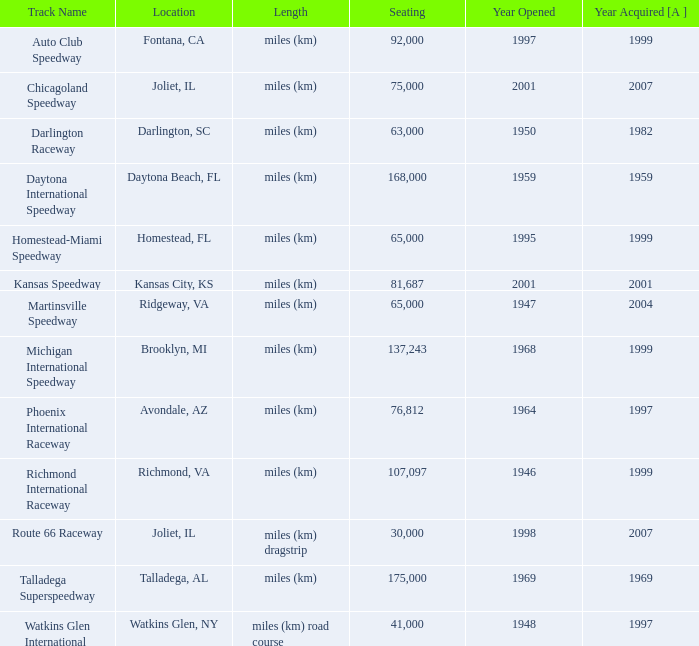In which year was the chicagoland speedway inaugurated with a capacity of less than 75,000 seats? None. 